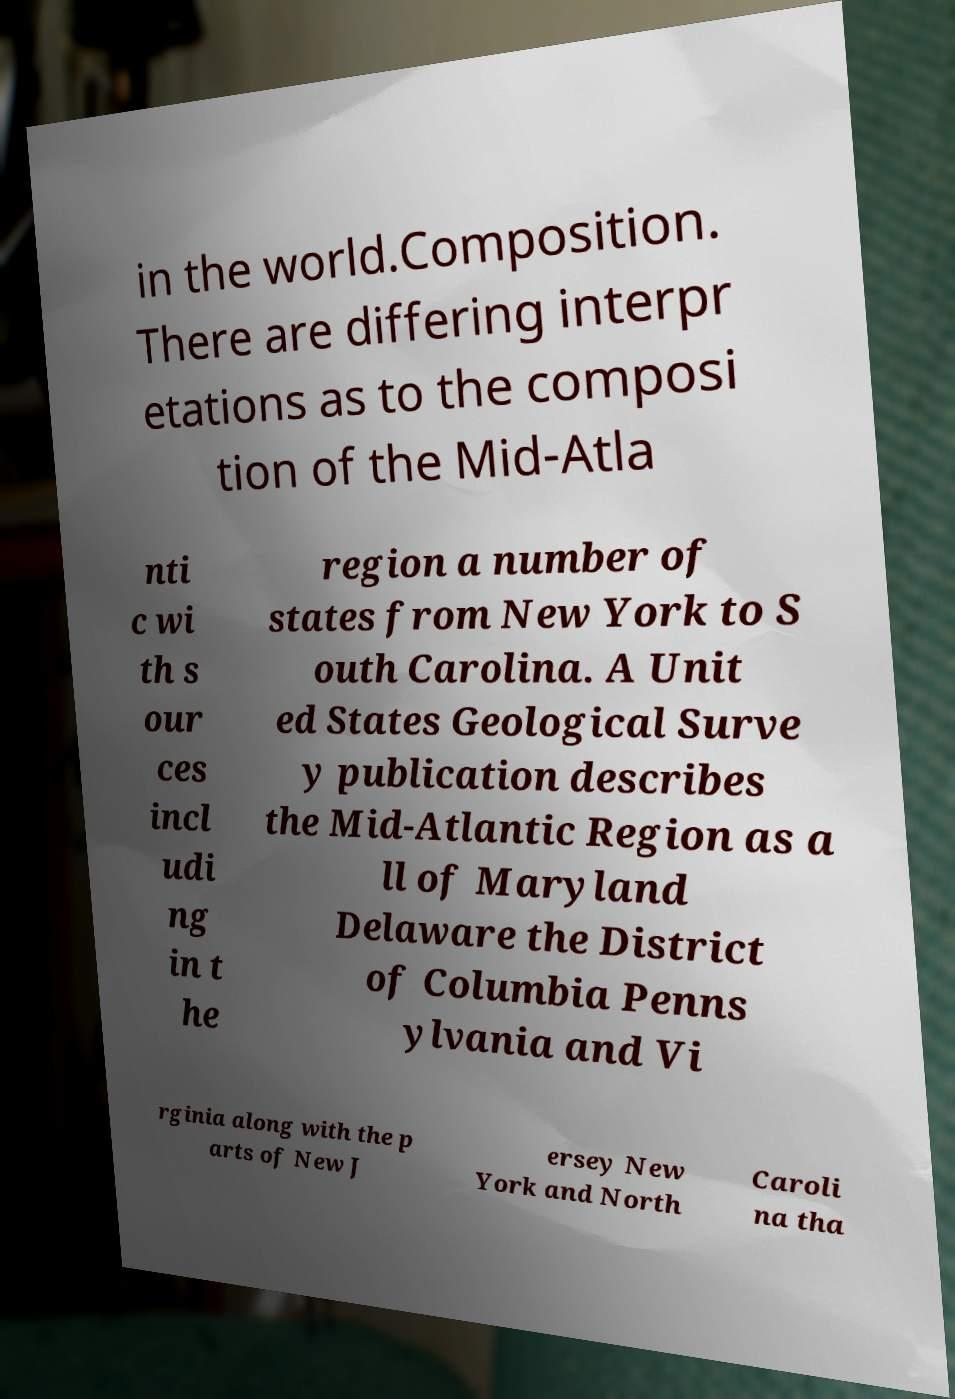Can you accurately transcribe the text from the provided image for me? in the world.Composition. There are differing interpr etations as to the composi tion of the Mid-Atla nti c wi th s our ces incl udi ng in t he region a number of states from New York to S outh Carolina. A Unit ed States Geological Surve y publication describes the Mid-Atlantic Region as a ll of Maryland Delaware the District of Columbia Penns ylvania and Vi rginia along with the p arts of New J ersey New York and North Caroli na tha 